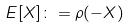Convert formula to latex. <formula><loc_0><loc_0><loc_500><loc_500>E [ X ] \colon = \rho ( - X )</formula> 